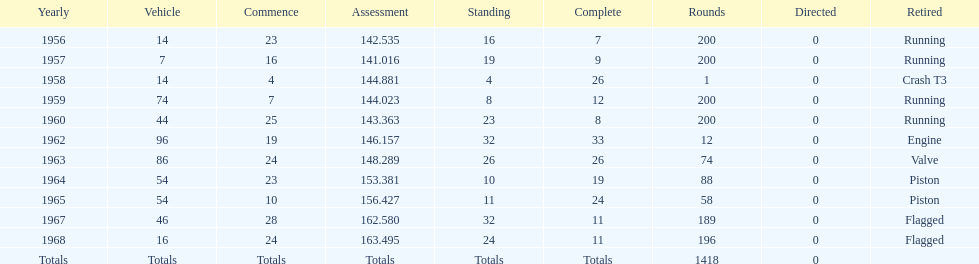What is the larger laps between 1963 or 1968 1968. 